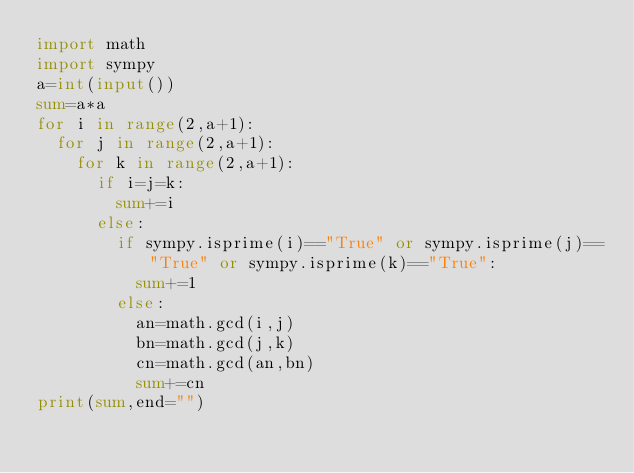<code> <loc_0><loc_0><loc_500><loc_500><_Python_>import math
import sympy
a=int(input())
sum=a*a
for i in range(2,a+1):
  for j in range(2,a+1):
    for k in range(2,a+1):
      if i=j=k:
        sum+=i
      else:
        if sympy.isprime(i)=="True" or sympy.isprime(j)=="True" or sympy.isprime(k)=="True":
          sum+=1
        else:
          an=math.gcd(i,j)
          bn=math.gcd(j,k)
          cn=math.gcd(an,bn)
          sum+=cn
print(sum,end="")</code> 